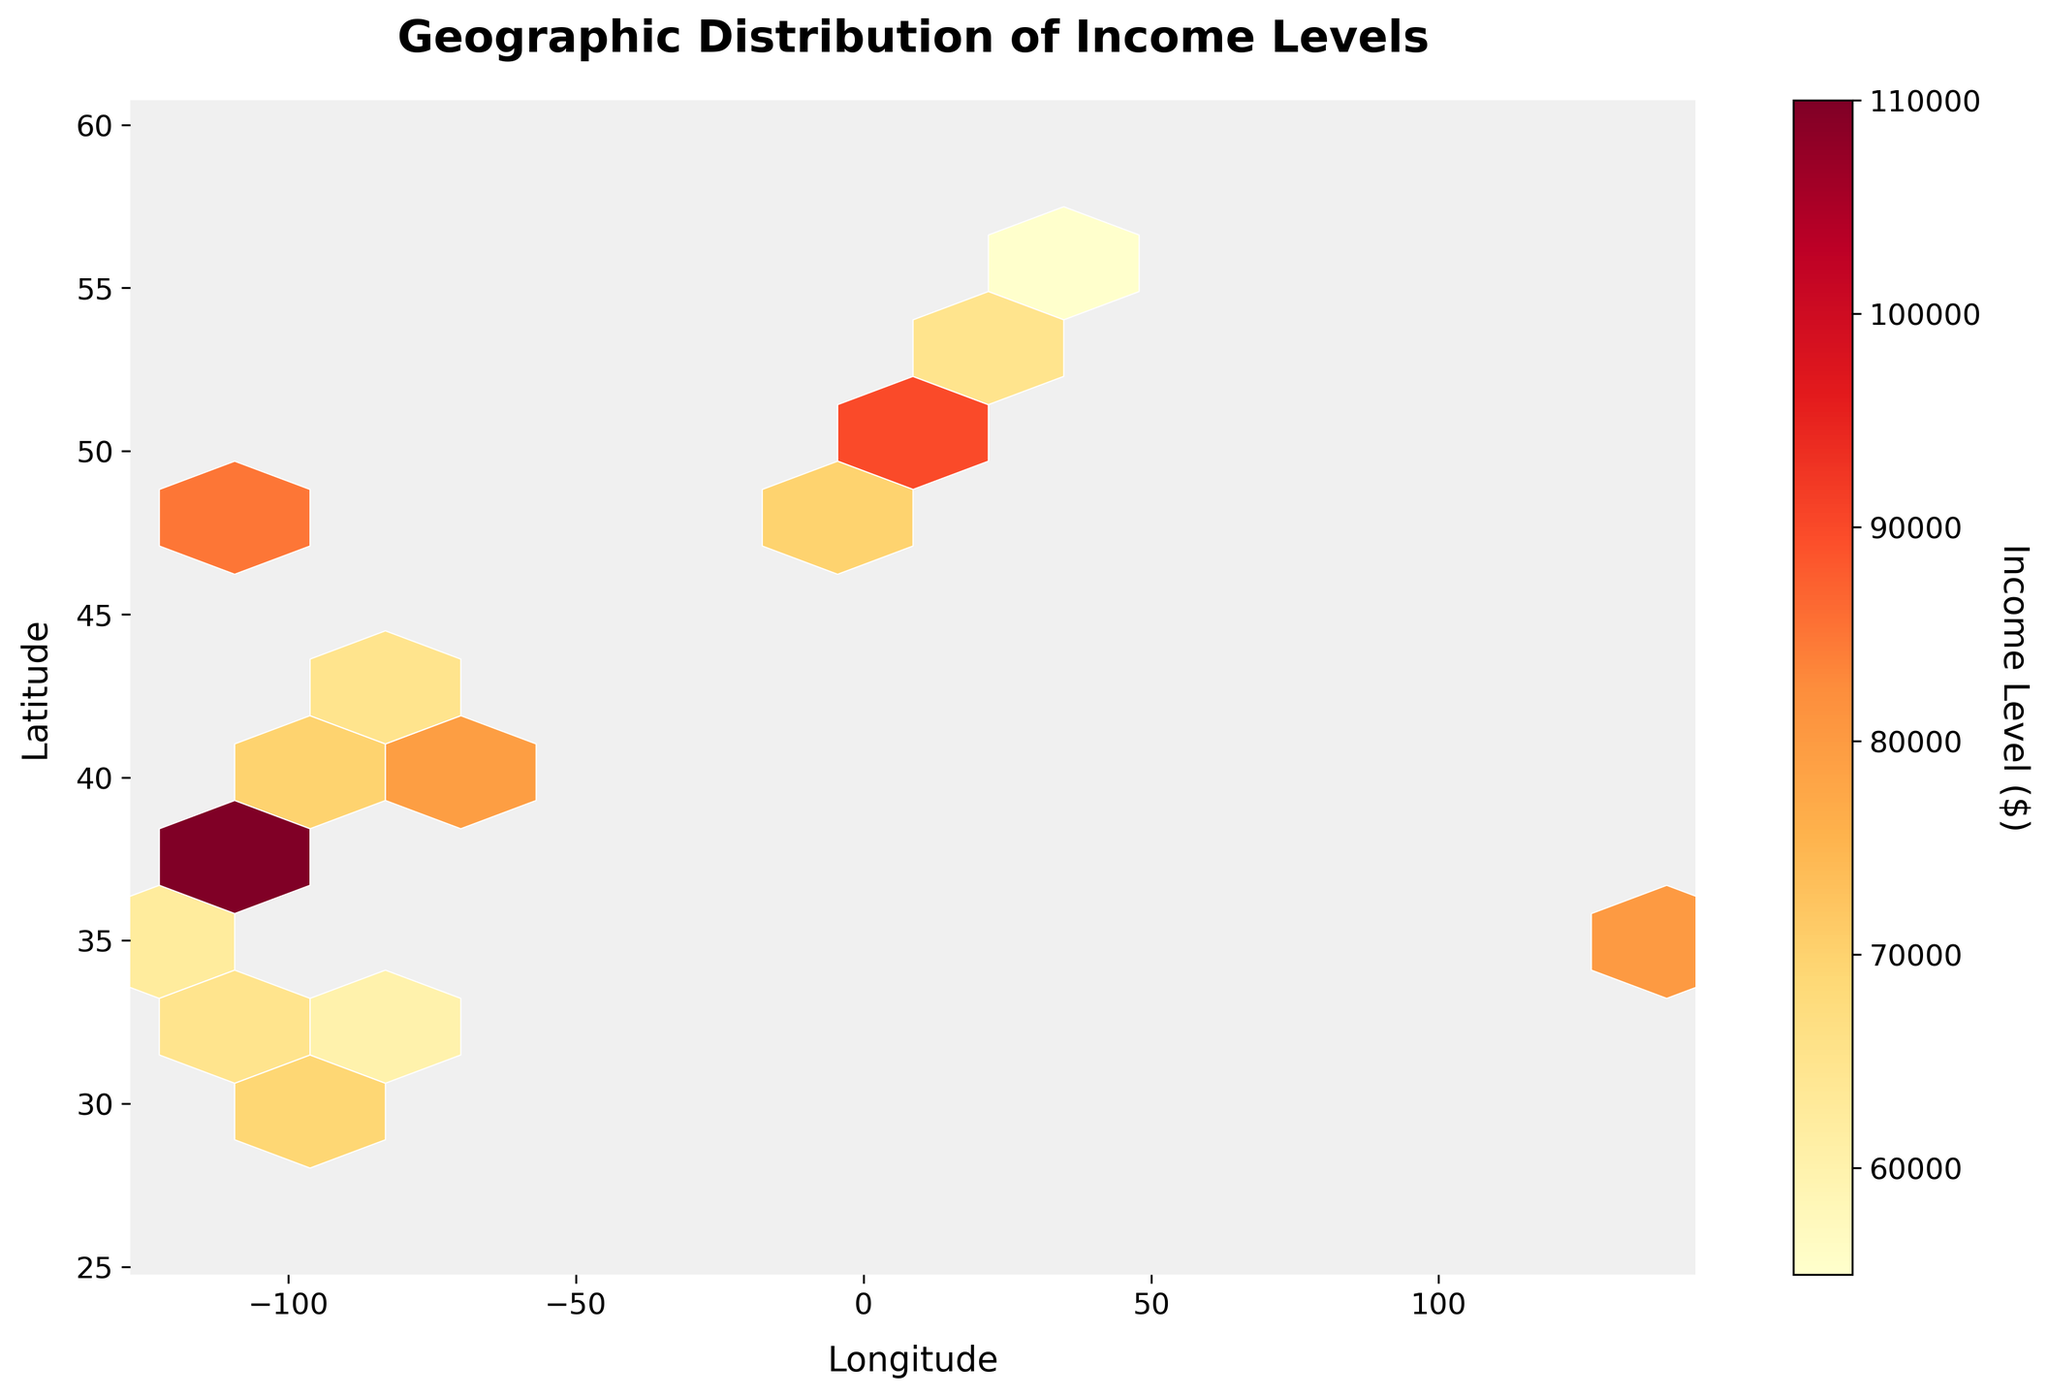What is the title of the figure? The title of the figure is typically located at the top in the largest font size compared to other text. In this figure, the title should reflect the data being visualized.
Answer: Geographic Distribution of Income Levels What variables are represented on the x-axis and y-axis? The axis labels directly define the variables. The x-axis label "Longitude" and the y-axis label "Latitude" help us understand the geographic coordinates used.
Answer: Longitude and Latitude What color indicates higher income levels? The color scale provided by the color bar shows a gradient from yellow to red. Higher income levels correspond to the darker end of the color spectrum (red).
Answer: Red How are income levels distributed across the geographic region? By examining the hexagonal bins, we can see clusters of darker colors (higher income levels) or lighter colors (lower income levels) and their spatial locations. Areas with more red hexagons have higher income levels, particularly in coastal and urban areas.
Answer: Clustered in coastal and urban areas Which area has the highest income level? The highest income levels are indicated by the darkest red hexagons. On the geographic map, San Francisco (37.7749, -122.4194) has the highest income level.
Answer: San Francisco Which areas show a higher concentration of potential customers based on income levels? To identify areas with higher concentrations, look for regions with more densely packed hexagons and darker colors. Coastal areas and major cities, such as New York, San Francisco, and Washington D.C., are examples.
Answer: New York, San Francisco, Washington D.C Is there a noticeable difference in income levels between eastern and western regions? A comparison of the color intensity between eastern and western regions reveals that the western region, particularly around San Francisco, has darker hexagons compared to other areas, indicating higher income levels. The east has significant areas with medium to high income levels (yellow to orange).
Answer: Yes, the western region, especially around San Francisco, tends to have higher income levels Are there any regions with a significantly low income level? Regions with lighter hexagons (yellow) indicate lower income levels. These regions are less frequent but can be identified around certain inland areas or smaller cities.
Answer: Inland and smaller cities What is the range of income levels shown by the color bar? The color bar typically shows the range of the variable it represents. Here, it labels the income levels from the minimum (probably light yellow) to the maximum (dark red).
Answer: The range spans from the lowest to the highest income levels depicted 